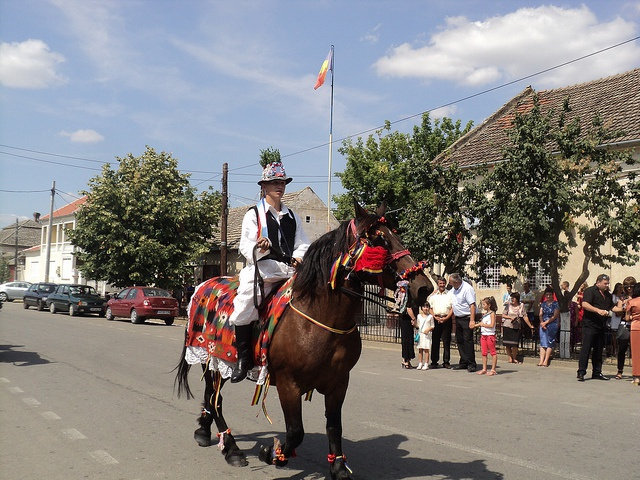Describe the objects in this image and their specific colors. I can see horse in darkgray, black, maroon, and gray tones, people in darkgray, black, white, and gray tones, people in darkgray, black, maroon, and gray tones, car in darkgray, black, maroon, brown, and gray tones, and people in darkgray, black, lavender, and gray tones in this image. 